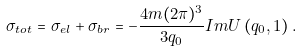Convert formula to latex. <formula><loc_0><loc_0><loc_500><loc_500>\sigma _ { t o t } = \sigma _ { e l } + \sigma _ { b r } = - \frac { 4 m ( 2 \pi ) ^ { 3 } } { 3 q _ { 0 } } { I m } U \left ( q _ { 0 } , 1 \right ) .</formula> 